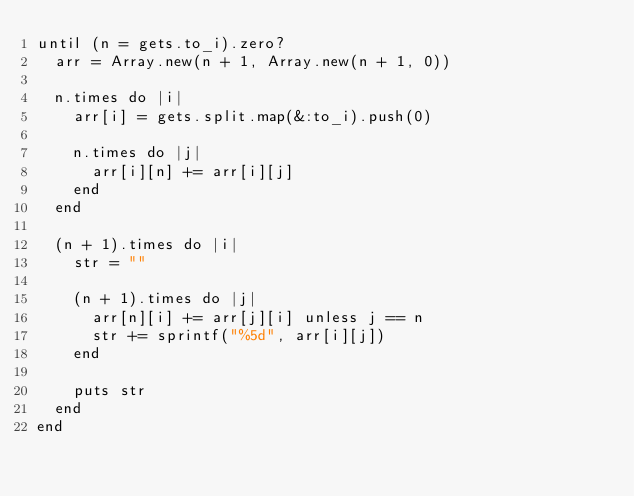Convert code to text. <code><loc_0><loc_0><loc_500><loc_500><_Ruby_>until (n = gets.to_i).zero?
  arr = Array.new(n + 1, Array.new(n + 1, 0))
  
  n.times do |i|
    arr[i] = gets.split.map(&:to_i).push(0)
    
    n.times do |j|
      arr[i][n] += arr[i][j]
    end
  end
  
  (n + 1).times do |i|
    str = ""
    
    (n + 1).times do |j|
      arr[n][i] += arr[j][i] unless j == n
      str += sprintf("%5d", arr[i][j])
    end
    
    puts str
  end
end</code> 